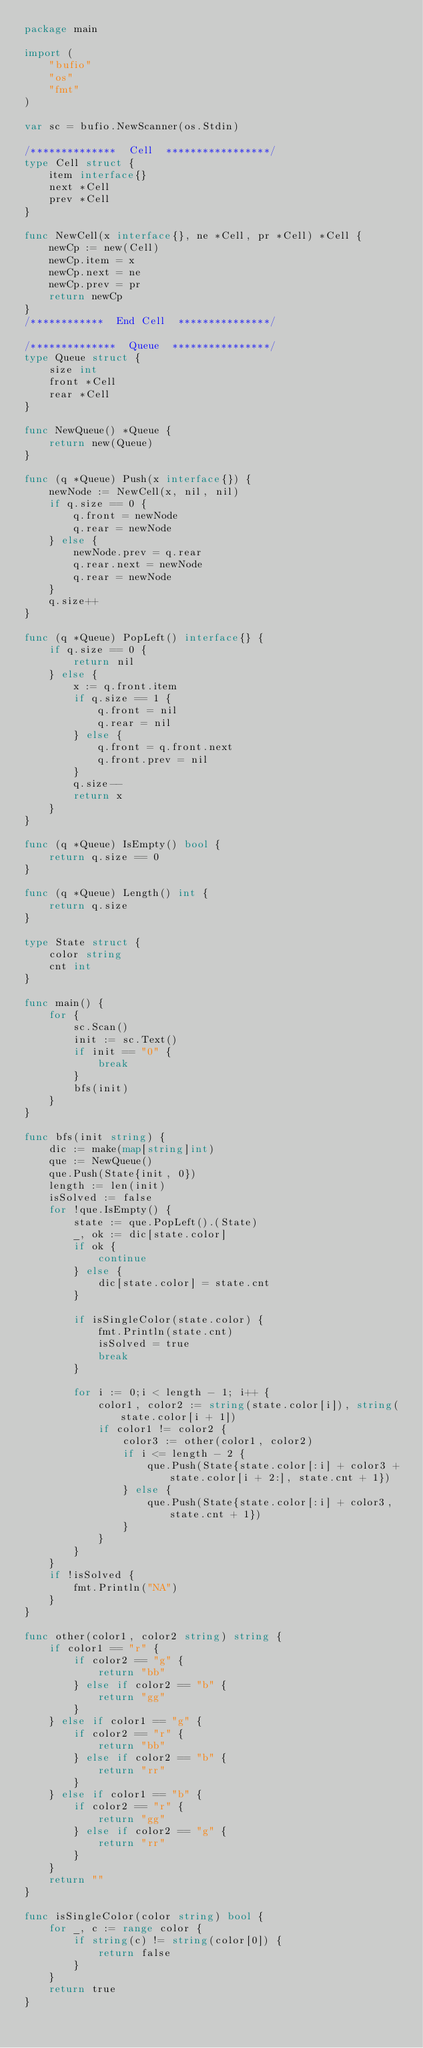Convert code to text. <code><loc_0><loc_0><loc_500><loc_500><_Go_>package main

import (
    "bufio"
    "os"
    "fmt"
)

var sc = bufio.NewScanner(os.Stdin)

/**************  Cell  *****************/
type Cell struct {
    item interface{}
    next *Cell
    prev *Cell
}

func NewCell(x interface{}, ne *Cell, pr *Cell) *Cell {
    newCp := new(Cell)
    newCp.item = x
    newCp.next = ne
    newCp.prev = pr
    return newCp
}
/************  End Cell  ***************/

/**************  Queue  ****************/
type Queue struct {
    size int
    front *Cell
    rear *Cell
}

func NewQueue() *Queue {
    return new(Queue)
}

func (q *Queue) Push(x interface{}) {
    newNode := NewCell(x, nil, nil)
    if q.size == 0 {
        q.front = newNode
        q.rear = newNode
    } else {
        newNode.prev = q.rear
        q.rear.next = newNode
        q.rear = newNode
    }
    q.size++
}

func (q *Queue) PopLeft() interface{} {
    if q.size == 0 {
        return nil
    } else {
        x := q.front.item
        if q.size == 1 {
            q.front = nil
            q.rear = nil
        } else {
            q.front = q.front.next
            q.front.prev = nil
        }
        q.size--
        return x
    }
}

func (q *Queue) IsEmpty() bool {
    return q.size == 0
}

func (q *Queue) Length() int {
    return q.size
}

type State struct {
    color string
    cnt int
}

func main() {
    for {
        sc.Scan()
        init := sc.Text()
        if init == "0" {
            break
        }
        bfs(init)
    }
}

func bfs(init string) {
    dic := make(map[string]int)
    que := NewQueue()
    que.Push(State{init, 0})
    length := len(init)
    isSolved := false
    for !que.IsEmpty() {
        state := que.PopLeft().(State)
        _, ok := dic[state.color]
        if ok {
            continue
        } else {
            dic[state.color] = state.cnt
        }

        if isSingleColor(state.color) {
            fmt.Println(state.cnt)
            isSolved = true
            break
        }

        for i := 0;i < length - 1; i++ {
            color1, color2 := string(state.color[i]), string(state.color[i + 1])
            if color1 != color2 {
                color3 := other(color1, color2)
                if i <= length - 2 {
                    que.Push(State{state.color[:i] + color3 + state.color[i + 2:], state.cnt + 1})
                } else {
                    que.Push(State{state.color[:i] + color3, state.cnt + 1})
                }
            }
        }
    }
    if !isSolved {
        fmt.Println("NA")
    }
}

func other(color1, color2 string) string {
    if color1 == "r" {
        if color2 == "g" {
            return "bb"
        } else if color2 == "b" {
            return "gg"
        }
    } else if color1 == "g" {
        if color2 == "r" {
            return "bb"
        } else if color2 == "b" {
            return "rr"
        }
    } else if color1 == "b" {
        if color2 == "r" {
            return "gg"
        } else if color2 == "g" {
            return "rr"
        }
    }
    return ""
}

func isSingleColor(color string) bool {
    for _, c := range color {
        if string(c) != string(color[0]) {
            return false
        }
    }
    return true
}
</code> 